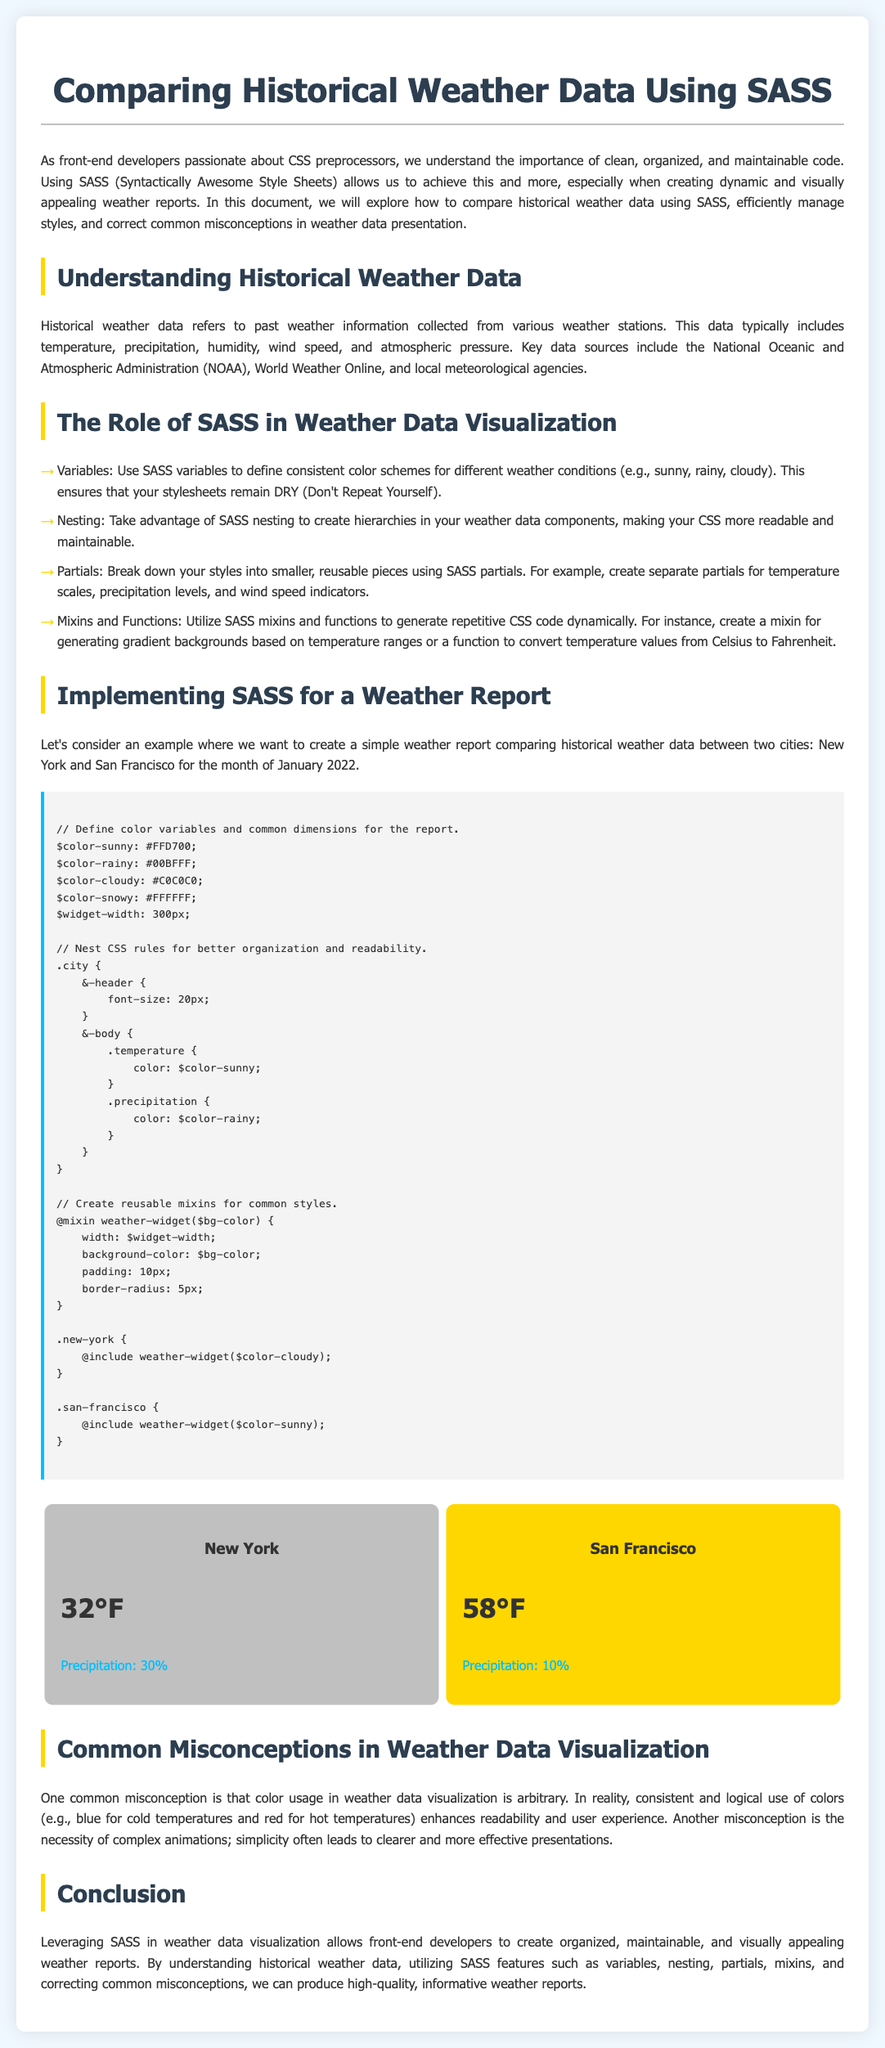What is the main title of the document? The main title is the heading displayed at the top of the document, indicating the document's subject.
Answer: Comparing Historical Weather Data Using SASS Which two cities are compared in the weather report? The cities compared in the document are explicitly listed in the city comparison section.
Answer: New York and San Francisco What temperature is recorded for New York? The temperature for New York is specifically mentioned in the city comparison section.
Answer: 32°F What is the precipitation percentage for San Francisco? The precipitation for San Francisco is provided as part of the city's weather data.
Answer: 10% How is SASS leveraged in weather data visualization? The document describes various SASS features utilized in creating visualizations, making the information clear.
Answer: Variables, Nesting, Partials, Mixins and Functions What common misconception is mentioned regarding color usage? The misconception regarding color usage in weather data visualization is highlighted in the document as part of the discussion on best practices.
Answer: Arbitrary What year is the historical weather data from? The document clearly states the month and year for which the historical weather data is presented.
Answer: January 2022 What background color is defined for the cloudy condition? The color mentioned for cloudy conditions is referenced in the style section of the document.
Answer: #C0C0C0 